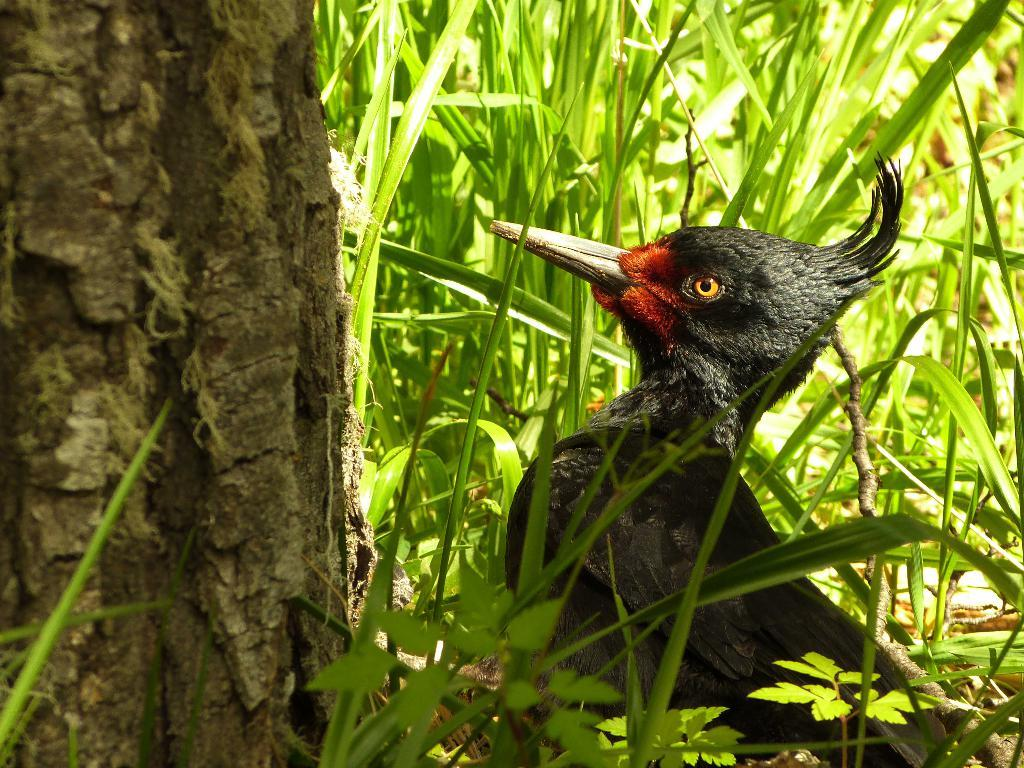What type of animal can be seen in the grass in the image? There is a bird in the grass in the image. What other object or feature can be seen in the image? There is a tree trunk visible in the image. What type of pocket can be seen on the bird in the image? There is no pocket visible on the bird in the image. 